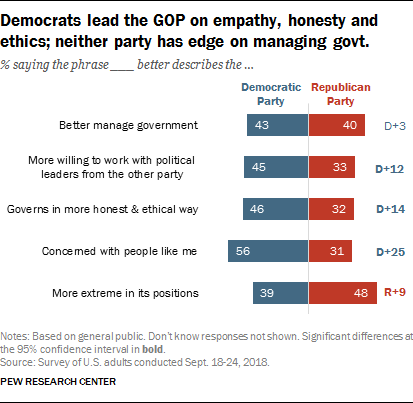Specify some key components in this picture. The value of the Democratic Party for better managing government is 43. The median of all blue bars is not greater than 45. 